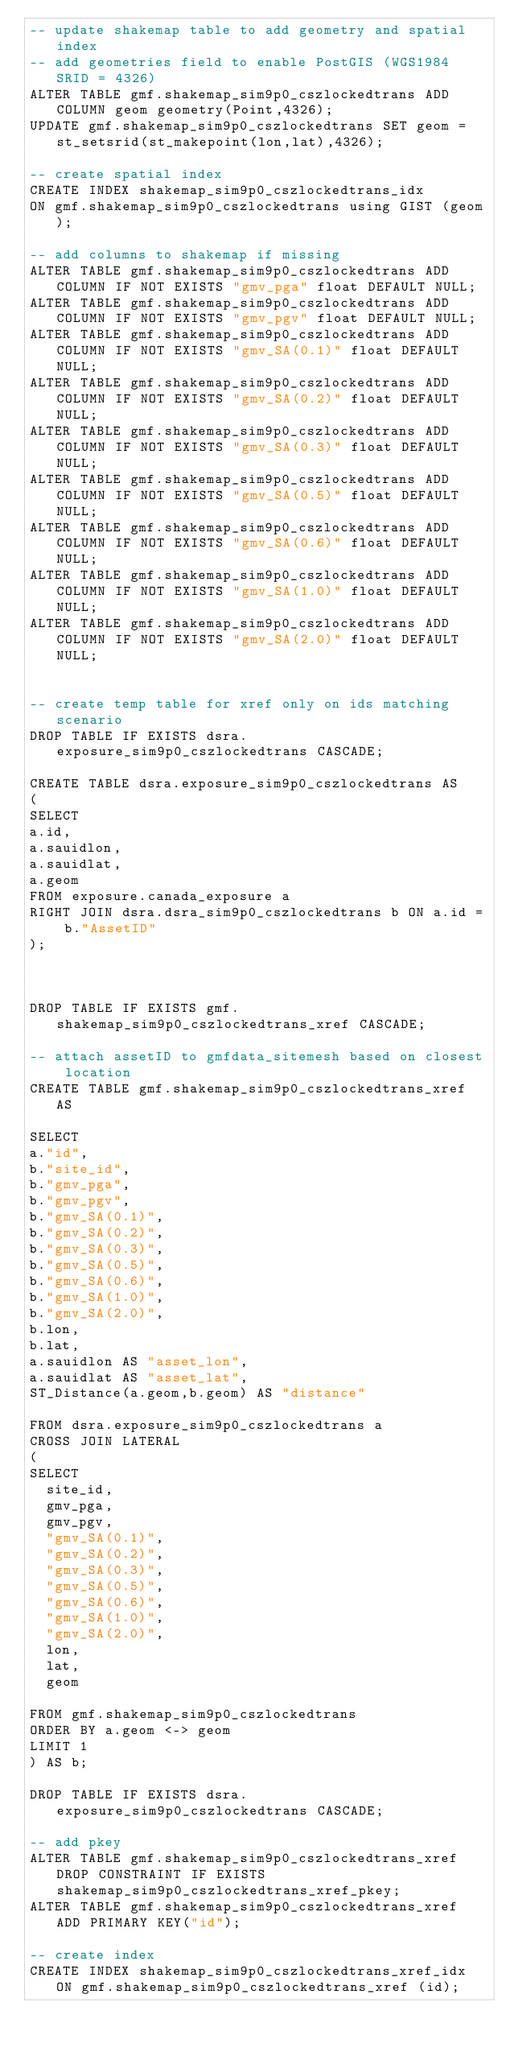<code> <loc_0><loc_0><loc_500><loc_500><_SQL_>-- update shakemap table to add geometry and spatial index
-- add geometries field to enable PostGIS (WGS1984 SRID = 4326)
ALTER TABLE gmf.shakemap_sim9p0_cszlockedtrans ADD COLUMN geom geometry(Point,4326);
UPDATE gmf.shakemap_sim9p0_cszlockedtrans SET geom = st_setsrid(st_makepoint(lon,lat),4326);

-- create spatial index
CREATE INDEX shakemap_sim9p0_cszlockedtrans_idx
ON gmf.shakemap_sim9p0_cszlockedtrans using GIST (geom);

-- add columns to shakemap if missing
ALTER TABLE gmf.shakemap_sim9p0_cszlockedtrans ADD COLUMN IF NOT EXISTS "gmv_pga" float DEFAULT NULL;
ALTER TABLE gmf.shakemap_sim9p0_cszlockedtrans ADD COLUMN IF NOT EXISTS "gmv_pgv" float DEFAULT NULL;
ALTER TABLE gmf.shakemap_sim9p0_cszlockedtrans ADD COLUMN IF NOT EXISTS "gmv_SA(0.1)" float DEFAULT NULL;
ALTER TABLE gmf.shakemap_sim9p0_cszlockedtrans ADD COLUMN IF NOT EXISTS "gmv_SA(0.2)" float DEFAULT NULL;
ALTER TABLE gmf.shakemap_sim9p0_cszlockedtrans ADD COLUMN IF NOT EXISTS "gmv_SA(0.3)" float DEFAULT NULL;
ALTER TABLE gmf.shakemap_sim9p0_cszlockedtrans ADD COLUMN IF NOT EXISTS "gmv_SA(0.5)" float DEFAULT NULL;
ALTER TABLE gmf.shakemap_sim9p0_cszlockedtrans ADD COLUMN IF NOT EXISTS "gmv_SA(0.6)" float DEFAULT NULL;
ALTER TABLE gmf.shakemap_sim9p0_cszlockedtrans ADD COLUMN IF NOT EXISTS "gmv_SA(1.0)" float DEFAULT NULL;
ALTER TABLE gmf.shakemap_sim9p0_cszlockedtrans ADD COLUMN IF NOT EXISTS "gmv_SA(2.0)" float DEFAULT NULL;


-- create temp table for xref only on ids matching scenario
DROP TABLE IF EXISTS dsra.exposure_sim9p0_cszlockedtrans CASCADE;

CREATE TABLE dsra.exposure_sim9p0_cszlockedtrans AS 
(
SELECT
a.id,
a.sauidlon,
a.sauidlat,
a.geom
FROM exposure.canada_exposure a
RIGHT JOIN dsra.dsra_sim9p0_cszlockedtrans b ON a.id = b."AssetID"
);



DROP TABLE IF EXISTS gmf.shakemap_sim9p0_cszlockedtrans_xref CASCADE;

-- attach assetID to gmfdata_sitemesh based on closest location
CREATE TABLE gmf.shakemap_sim9p0_cszlockedtrans_xref AS

SELECT
a."id",
b."site_id",
b."gmv_pga",
b."gmv_pgv",
b."gmv_SA(0.1)",
b."gmv_SA(0.2)",
b."gmv_SA(0.3)",
b."gmv_SA(0.5)",
b."gmv_SA(0.6)",
b."gmv_SA(1.0)",
b."gmv_SA(2.0)",
b.lon,
b.lat,
a.sauidlon AS "asset_lon",
a.sauidlat AS "asset_lat",
ST_Distance(a.geom,b.geom) AS "distance"

FROM dsra.exposure_sim9p0_cszlockedtrans a
CROSS JOIN LATERAL 
(
SELECT
	site_id,
	gmv_pga,
	gmv_pgv,
	"gmv_SA(0.1)",
	"gmv_SA(0.2)",
	"gmv_SA(0.3)",
	"gmv_SA(0.5)",
	"gmv_SA(0.6)",
	"gmv_SA(1.0)",
	"gmv_SA(2.0)",
	lon,
	lat,
	geom
	
FROM gmf.shakemap_sim9p0_cszlockedtrans
ORDER BY a.geom <-> geom
LIMIT 1
) AS b;

DROP TABLE IF EXISTS dsra.exposure_sim9p0_cszlockedtrans CASCADE;

-- add pkey
ALTER TABLE gmf.shakemap_sim9p0_cszlockedtrans_xref DROP CONSTRAINT IF EXISTS shakemap_sim9p0_cszlockedtrans_xref_pkey;
ALTER TABLE gmf.shakemap_sim9p0_cszlockedtrans_xref ADD PRIMARY KEY("id");

-- create index
CREATE INDEX shakemap_sim9p0_cszlockedtrans_xref_idx ON gmf.shakemap_sim9p0_cszlockedtrans_xref (id);</code> 